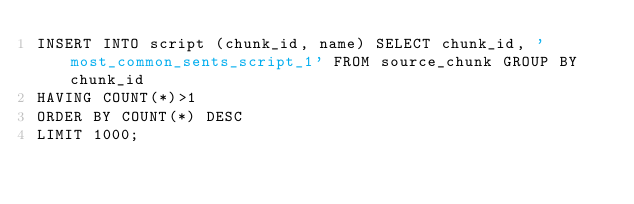<code> <loc_0><loc_0><loc_500><loc_500><_SQL_>INSERT INTO script (chunk_id, name) SELECT chunk_id, 'most_common_sents_script_1' FROM source_chunk GROUP BY chunk_id
HAVING COUNT(*)>1
ORDER BY COUNT(*) DESC
LIMIT 1000;



</code> 